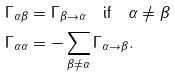Convert formula to latex. <formula><loc_0><loc_0><loc_500><loc_500>\Gamma _ { \alpha \beta } & = \Gamma _ { \beta \rightarrow \alpha } \quad \text {if} \quad \alpha \neq \beta \\ \Gamma _ { \alpha \alpha } & = - \sum _ { \beta \neq \alpha } \Gamma _ { \alpha \rightarrow \beta } .</formula> 